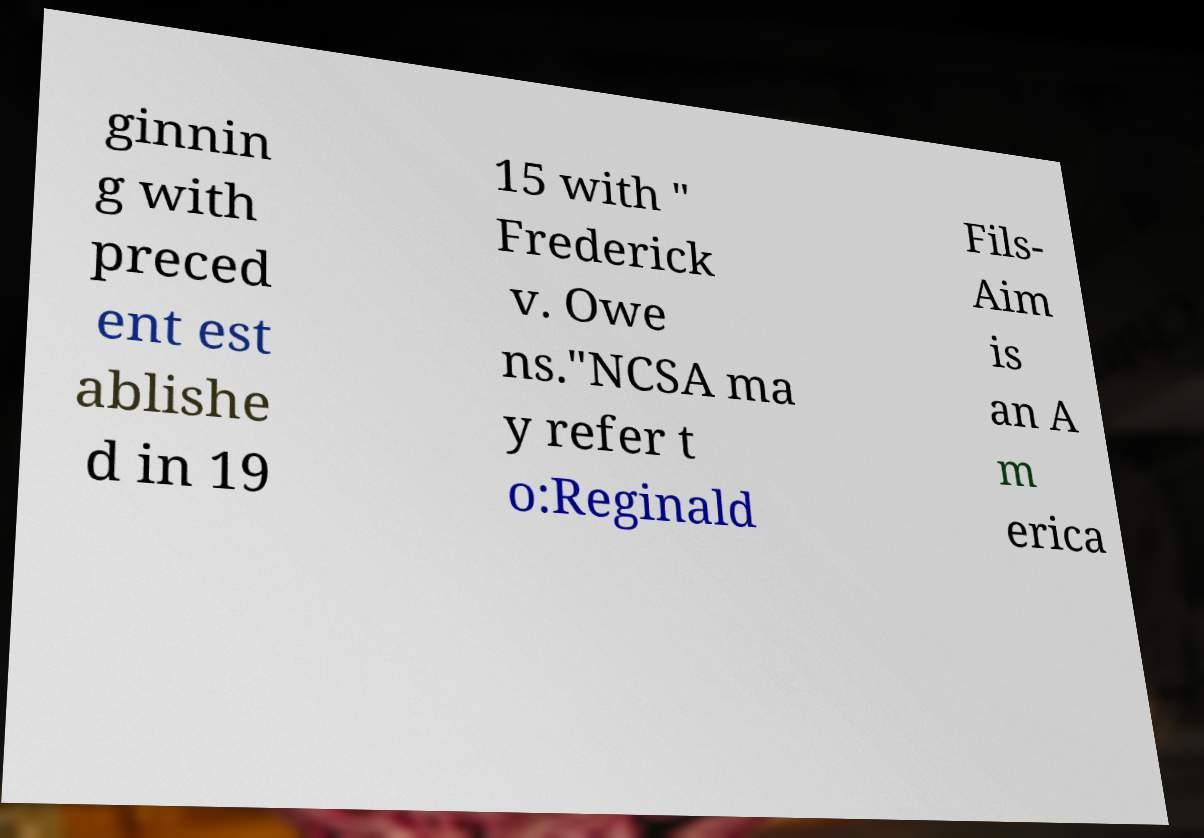Please read and relay the text visible in this image. What does it say? ginnin g with preced ent est ablishe d in 19 15 with " Frederick v. Owe ns."NCSA ma y refer t o:Reginald Fils- Aim is an A m erica 